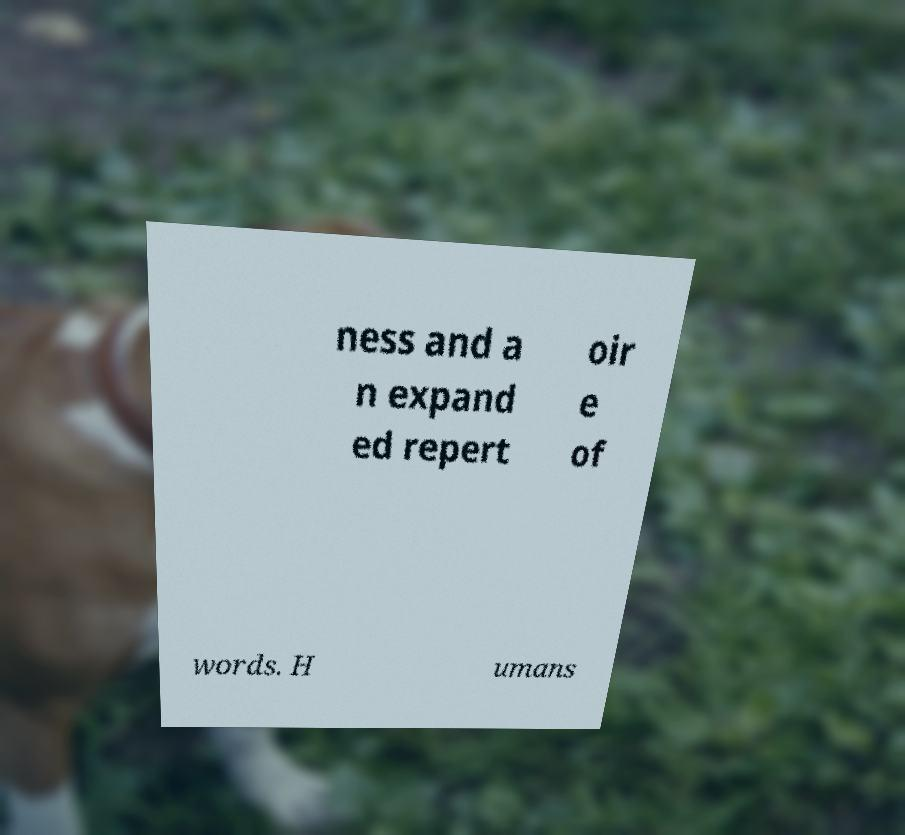I need the written content from this picture converted into text. Can you do that? ness and a n expand ed repert oir e of words. H umans 